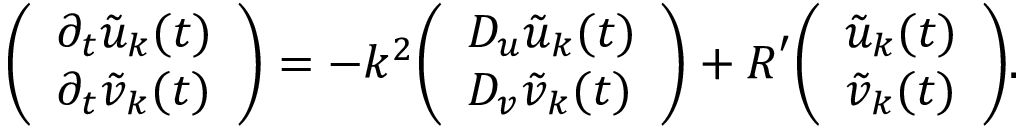Convert formula to latex. <formula><loc_0><loc_0><loc_500><loc_500>{ \left ( \begin{array} { l } { \partial _ { t } { \tilde { u } } _ { k } ( t ) } \\ { \partial _ { t } { \tilde { v } } _ { k } ( t ) } \end{array} \right ) } = - k ^ { 2 } { \left ( \begin{array} { l } { D _ { u } { \tilde { u } } _ { k } ( t ) } \\ { D _ { v } { \tilde { v } } _ { k } ( t ) } \end{array} \right ) } + { R } ^ { \prime } { \left ( \begin{array} { l } { { \tilde { u } } _ { k } ( t ) } \\ { { \tilde { v } } _ { k } ( t ) } \end{array} \right ) } .</formula> 